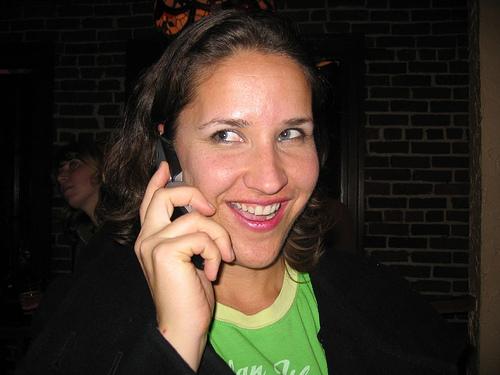What is the woman doing with the phone?
Keep it brief. Talking. Does this woman look happy?
Answer briefly. Yes. How many fingers do you see?
Short answer required. 4. What color is the womans collar?
Be succinct. Yellow. Is she wearing any jewelry?
Give a very brief answer. No. What color lipstick is the woman wearing?
Give a very brief answer. Pink. Is she sad?
Short answer required. No. 